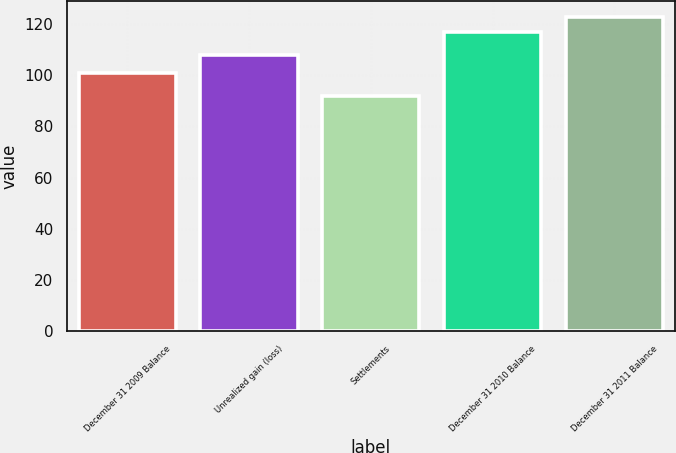<chart> <loc_0><loc_0><loc_500><loc_500><bar_chart><fcel>December 31 2009 Balance<fcel>Unrealized gain (loss)<fcel>Settlements<fcel>December 31 2010 Balance<fcel>December 31 2011 Balance<nl><fcel>101<fcel>108<fcel>92<fcel>117<fcel>123<nl></chart> 